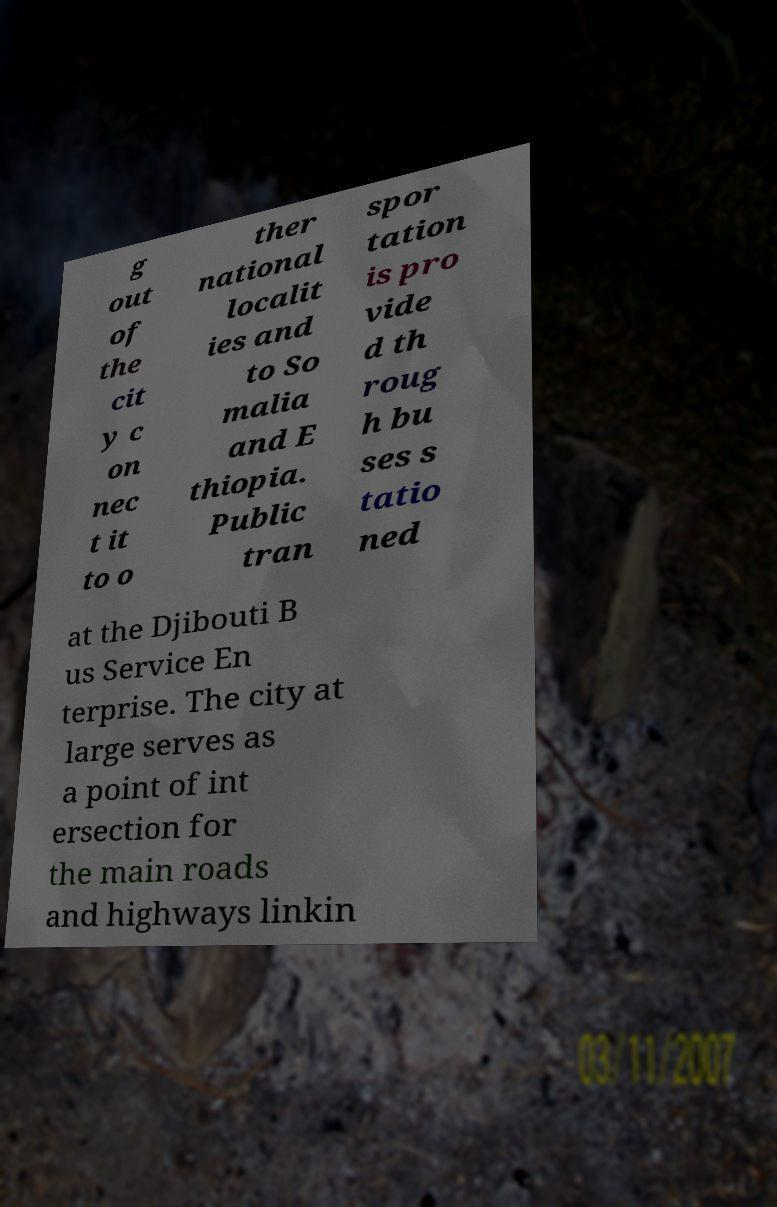Could you extract and type out the text from this image? g out of the cit y c on nec t it to o ther national localit ies and to So malia and E thiopia. Public tran spor tation is pro vide d th roug h bu ses s tatio ned at the Djibouti B us Service En terprise. The city at large serves as a point of int ersection for the main roads and highways linkin 